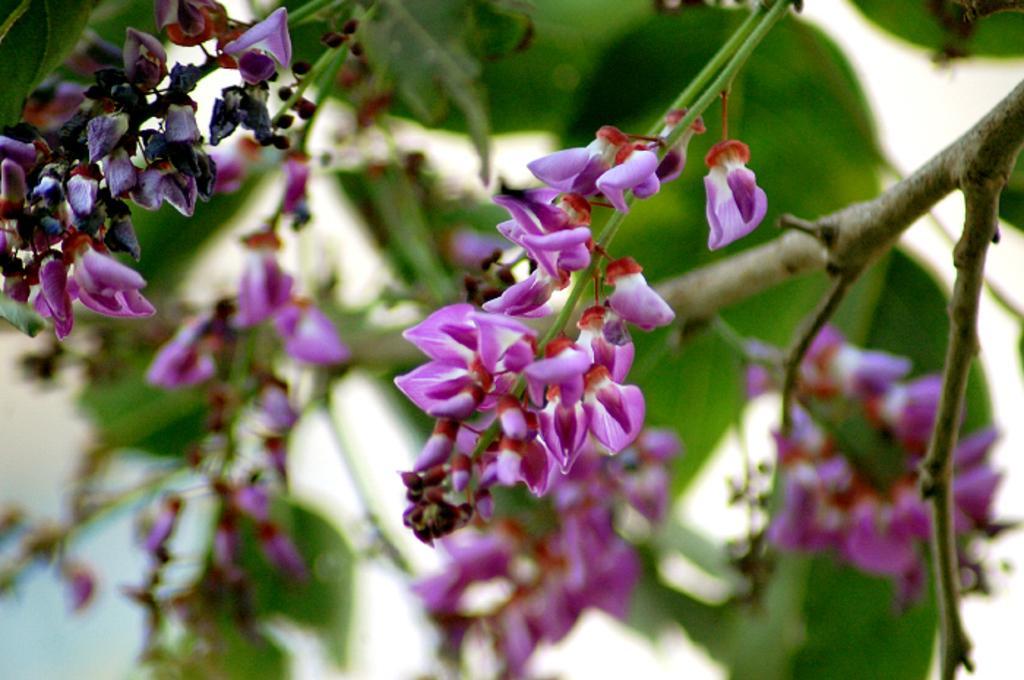Please provide a concise description of this image. There is a tree which has violet color flowers on it. 